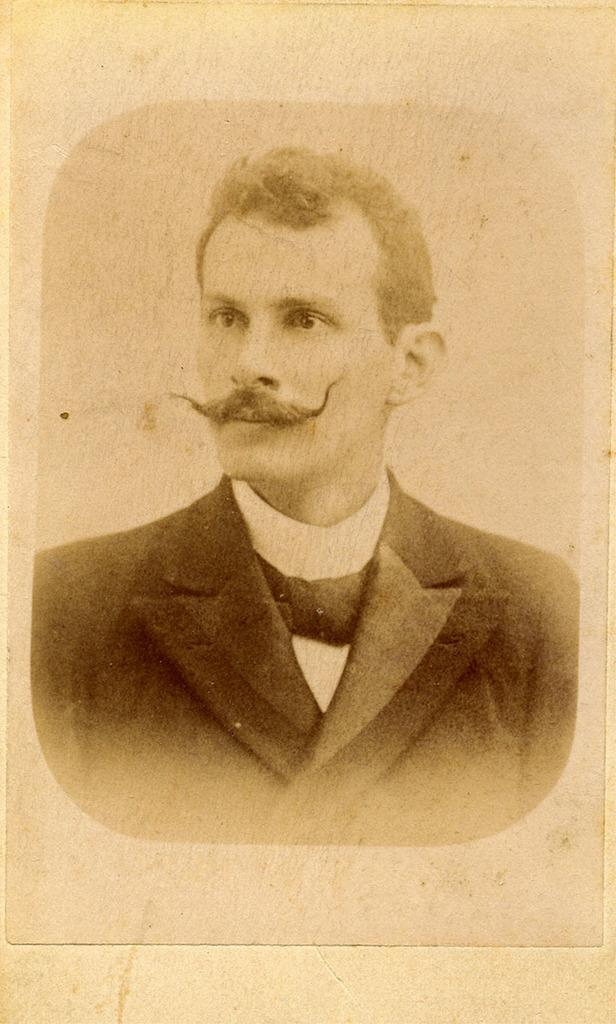What is the main subject of the image? There is a photo of a man in the image. What type of pig is the man reading about in the image? There is no pig or reading activity present in the image; it only features a photo of a man. 